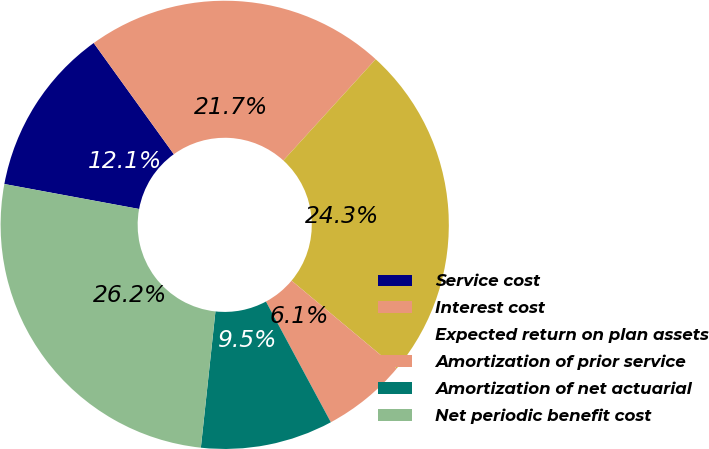<chart> <loc_0><loc_0><loc_500><loc_500><pie_chart><fcel>Service cost<fcel>Interest cost<fcel>Expected return on plan assets<fcel>Amortization of prior service<fcel>Amortization of net actuarial<fcel>Net periodic benefit cost<nl><fcel>12.15%<fcel>21.7%<fcel>24.31%<fcel>6.08%<fcel>9.55%<fcel>26.22%<nl></chart> 